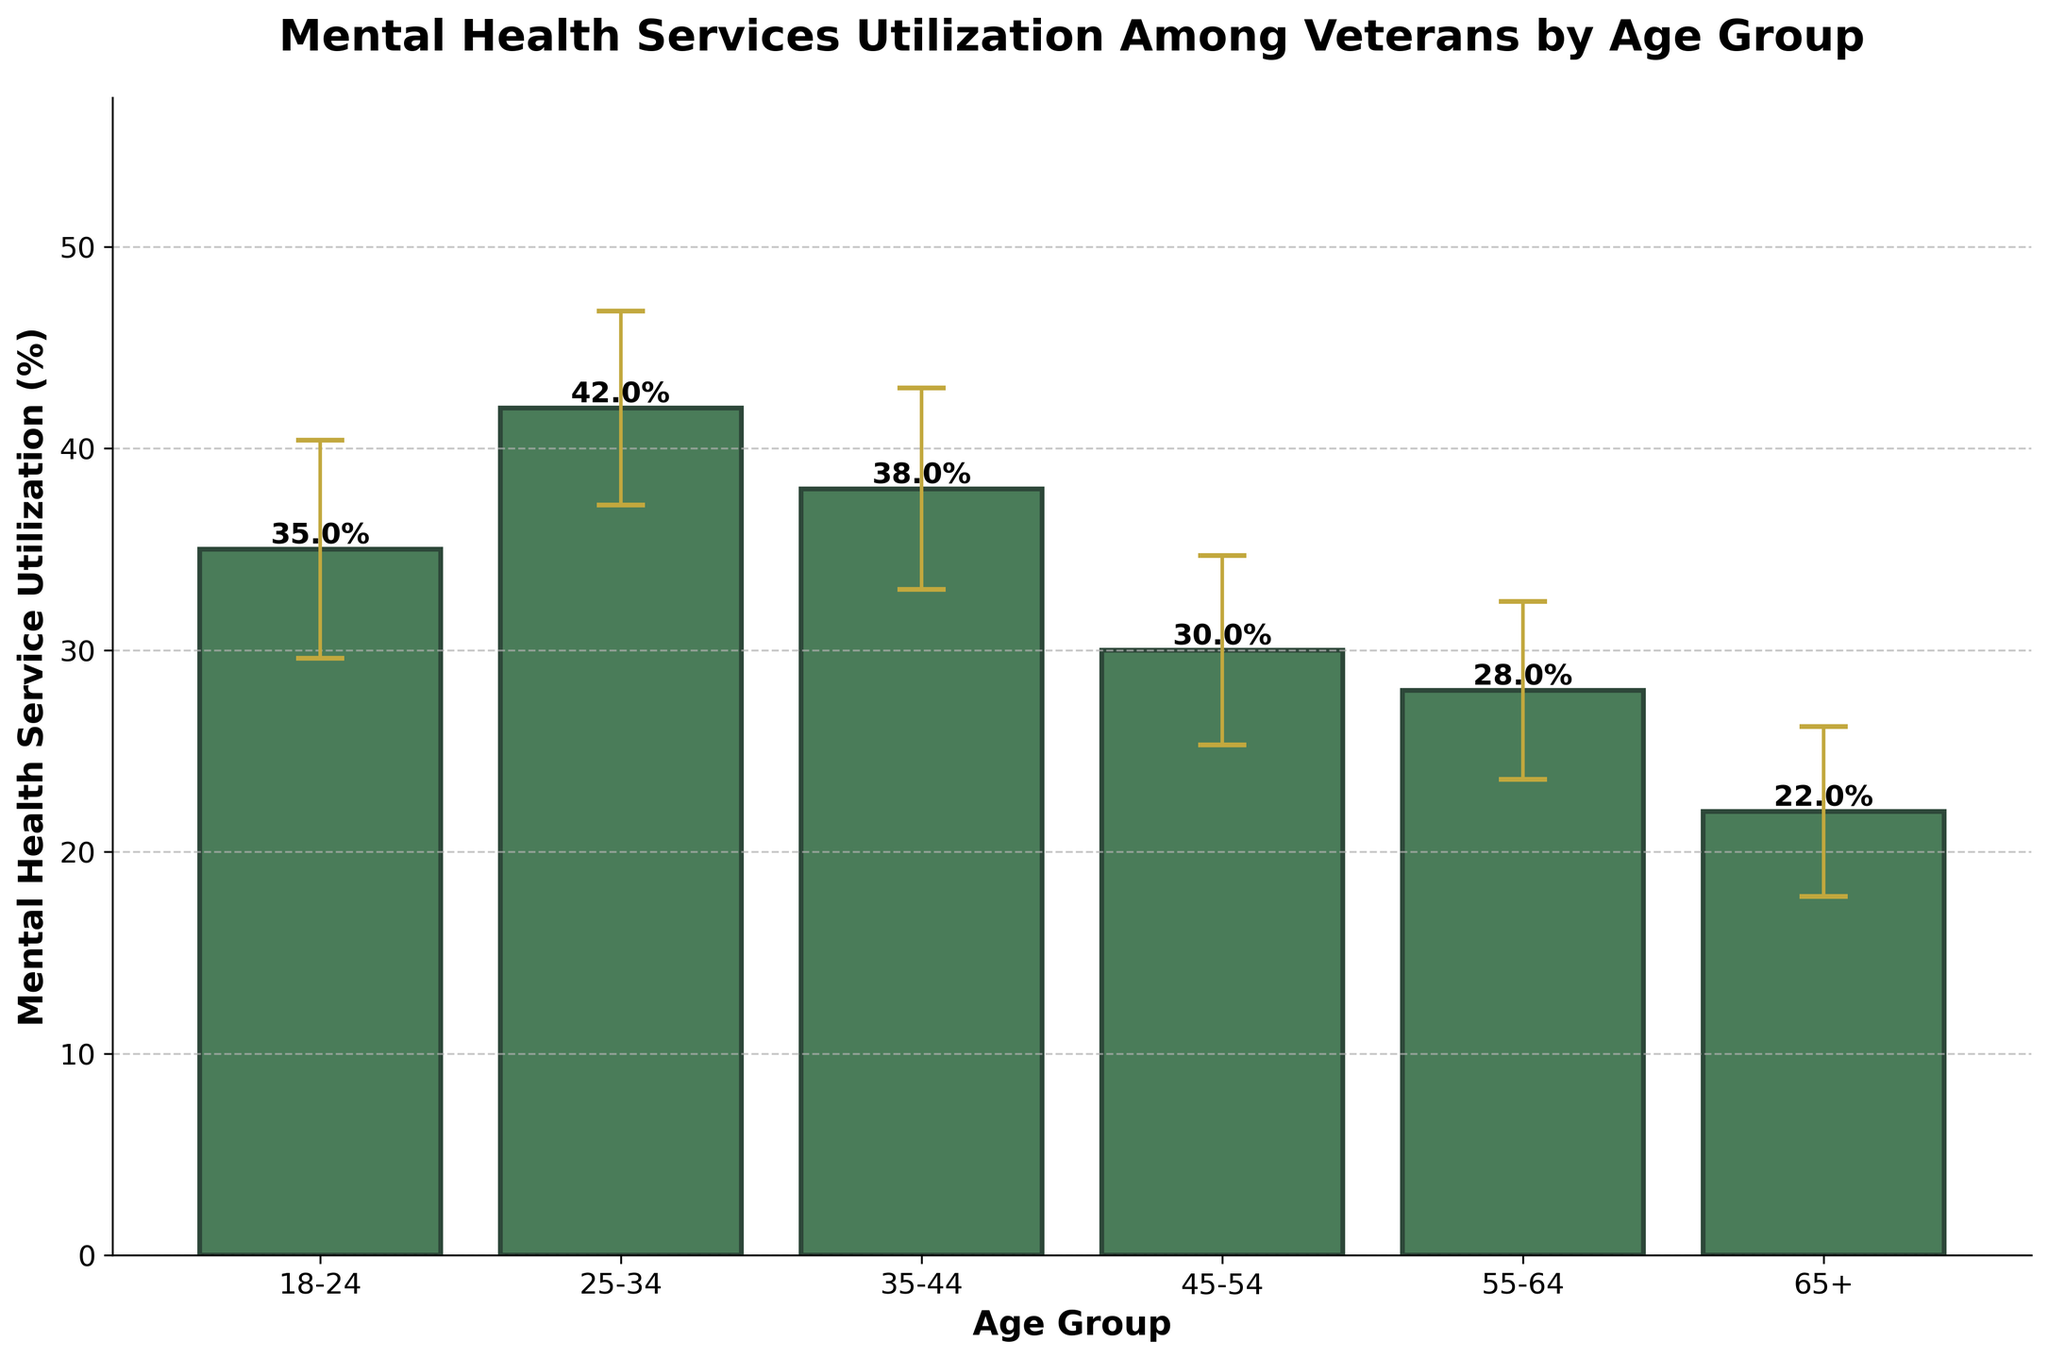What is the title of the figure? The title of the figure is usually displayed at the top and summarizes the contents of the chart. By reading the topmost text of the chart, we can see the title.
Answer: Mental Health Services Utilization Among Veterans by Age Group What are the age groups shown in the chart? The age groups are displayed on the x-axis of the bar chart. Each bar represents a different age group. By looking at each label on the x-axis, we can identify the age groups.
Answer: 18-24, 25-34, 35-44, 45-54, 55-64, 65+ Which age group has the highest mental health service utilization? To determine the highest utilization, we look for the tallest bar in the chart. The height of each bar indicates the percentage utilization for that age group.
Answer: 25-34 What is the mental health service utilization percentage for the 55-64 age group? We find the bar corresponding to the 55-64 age group on the x-axis and examine its height, which should be labeled with the exact percentage at the top of the bar.
Answer: 28% What is the difference in mental health service utilization between the 18-24 and 65+ age groups? First, we find the utilization percentages for 18-24 and 65+ age groups (35% and 22%, respectively). Then, we subtract the smaller value from the larger one.
Answer: 13% Which age group has the smallest standard deviation for mental health service utilization? The standard deviation is represented by the error bars extending from the top of each bar. We identify the age group with the shortest error bars.
Answer: 65+ Between the age groups 35-44 and 45-54, which one has a higher utilization, and by how much? We first check the heights of the bars for the 35-44 (38%) and 45-54 (30%) age groups respectively. Then, we subtract 30% from 38% to find the difference.
Answer: 35-44, by 8% What is the average mental health service utilization percentage across all age groups? To calculate the average, we sum all the utilization percentages (35 + 42 + 38 + 30 + 28 + 22) and then divide by the number of age groups (6).
Answer: 32.5% How do the error bars affect our confidence in the utilization percentages? The error bars show the standard deviation around the mean utilization percentages. Larger error bars indicate higher variability and less confidence in the pinpoint accuracy of the percentage shown, while shorter error bars indicate more precision. By comparing the lengths of the error bars, we see the variability in the data for each age group.
Answer: Indicates variability in data What is the range of utilization percentages across all age groups? The range is found by subtracting the lowest utilization percentage (22%) from the highest utilization percentage (42%).
Answer: 20% 